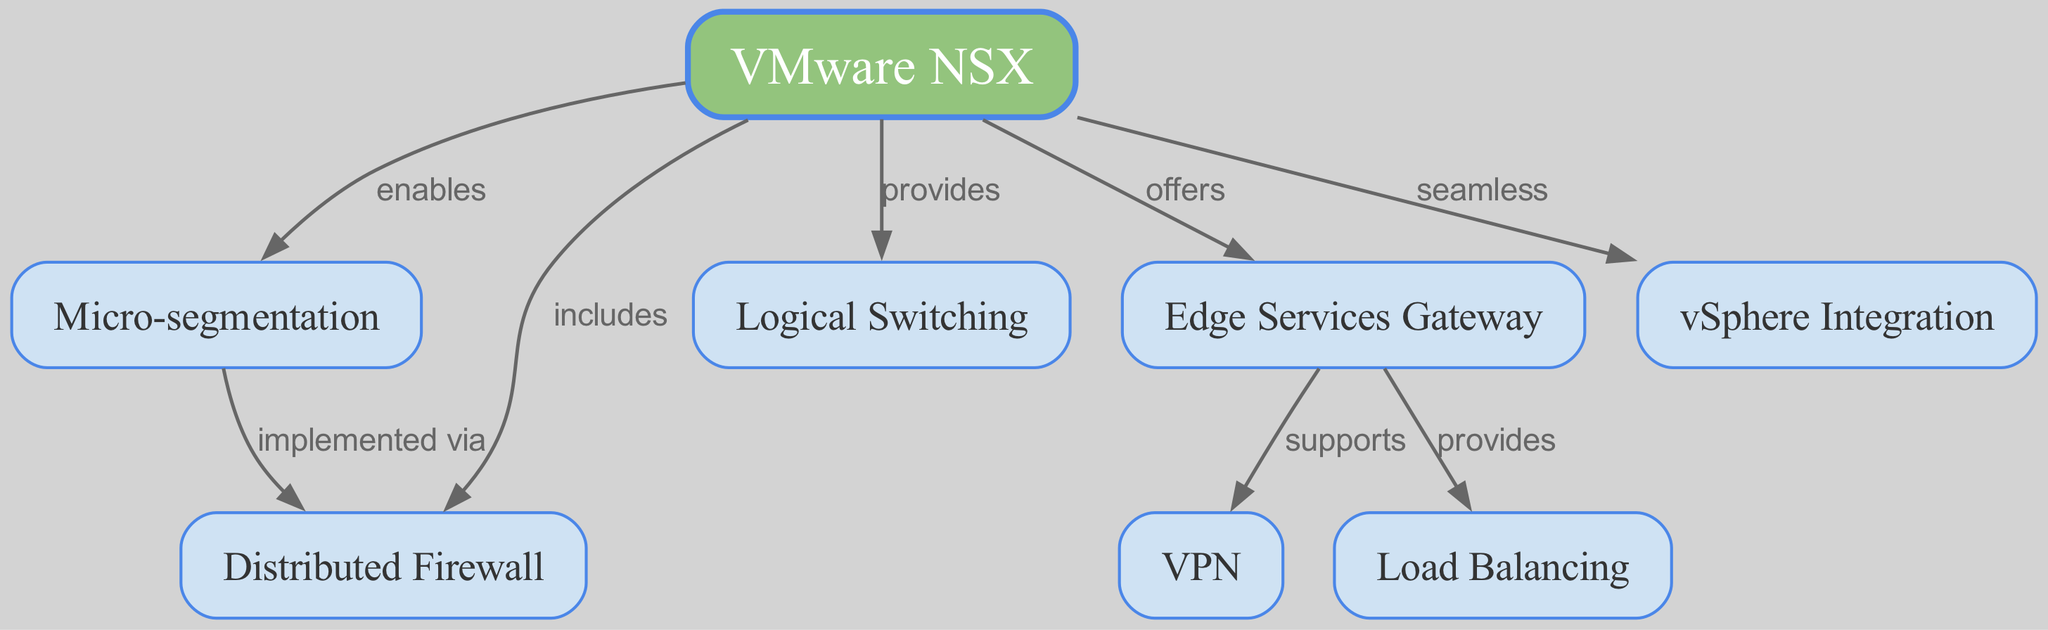What is the central node of the diagram? The central node of the diagram is "VMware NSX," as it connects to all other nodes and serves as the primary focus of the concept map.
Answer: VMware NSX How many nodes are present in total? By counting the nodes listed in the diagram, there are 8 distinct nodes represented.
Answer: 8 What relationship does "Micro-segmentation" have with "Distributed Firewall"? The relationship is shown as "implemented via," indicating that micro-segmentation utilizes the distributed firewall as a method or technique for security.
Answer: implemented via Which services does the "Edge Services Gateway" support? The Edge Services Gateway supports "VPN," which indicates its capability to provide secure remote connections.
Answer: VPN What does "VMware NSX" provide in relation to "Logical Switching"? The diagram shows that "VMware NSX" provides "Logical Switching," which illustrates NSX's functionality in managing virtual networks.
Answer: Logical Switching How many edges are connected to "VMware NSX"? Counting the edges, "VMware NSX" has 6 edges connecting it to other nodes, indicating its central role in the network security measures.
Answer: 6 What does "Edge Services Gateway" provide? The Edge Services Gateway provides "Load Balancing," which ensures efficient distribution of network traffic across multiple servers.
Answer: Load Balancing What is the primary function attributed to "Micro-segmentation"? The primary function attributed to micro-segmentation is to enable security measures that isolate different workloads within virtualized environments.
Answer: enable What kind of integration does "VMware NSX" have with "vSphere"? The diagram indicates that "VMware NSX" allows for "seamless" integration with vSphere, signifying a smooth operation between the two technologies.
Answer: seamless 